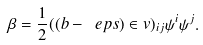Convert formula to latex. <formula><loc_0><loc_0><loc_500><loc_500>\beta = \frac { 1 } { 2 } ( ( b - \ e p s ) \in v ) _ { i j } \psi ^ { i } \psi ^ { j } .</formula> 